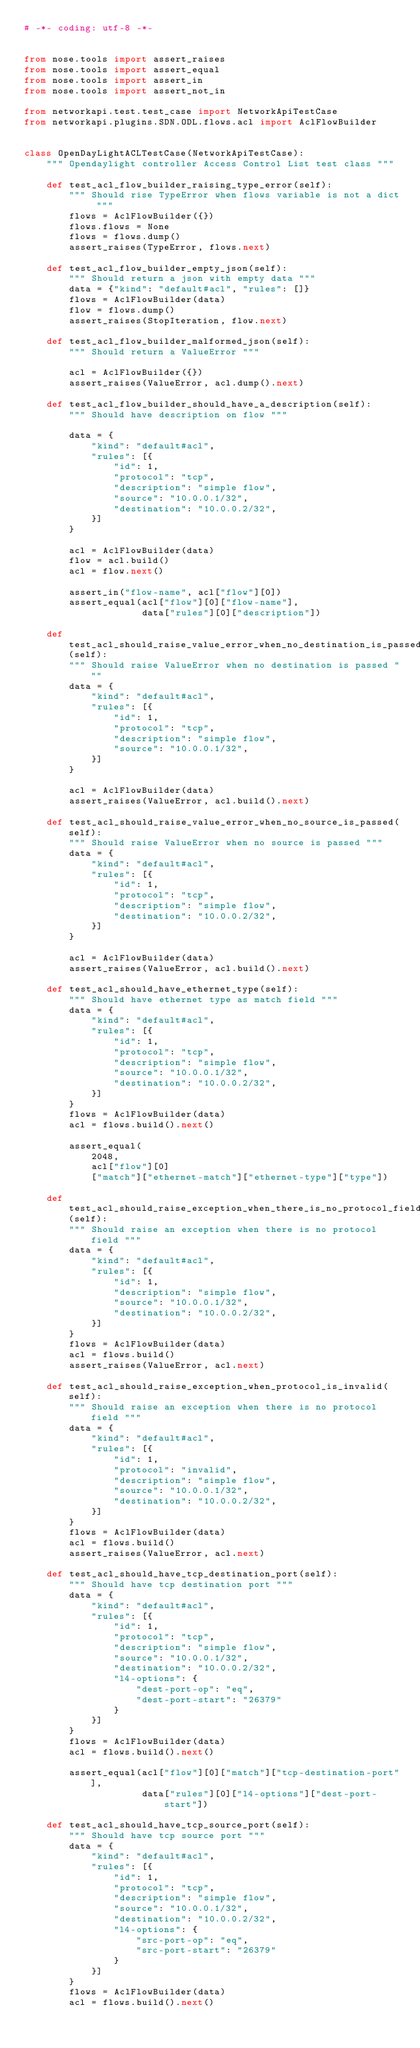<code> <loc_0><loc_0><loc_500><loc_500><_Python_># -*- coding: utf-8 -*-


from nose.tools import assert_raises
from nose.tools import assert_equal
from nose.tools import assert_in
from nose.tools import assert_not_in

from networkapi.test.test_case import NetworkApiTestCase
from networkapi.plugins.SDN.ODL.flows.acl import AclFlowBuilder


class OpenDayLightACLTestCase(NetworkApiTestCase):
    """ Opendaylight controller Access Control List test class """

    def test_acl_flow_builder_raising_type_error(self):
        """ Should rise TypeError when flows variable is not a dict """
        flows = AclFlowBuilder({})
        flows.flows = None
        flows = flows.dump()
        assert_raises(TypeError, flows.next)

    def test_acl_flow_builder_empty_json(self):
        """ Should return a json with empty data """
        data = {"kind": "default#acl", "rules": []}
        flows = AclFlowBuilder(data)
        flow = flows.dump()
        assert_raises(StopIteration, flow.next)

    def test_acl_flow_builder_malformed_json(self):
        """ Should return a ValueError """

        acl = AclFlowBuilder({})
        assert_raises(ValueError, acl.dump().next)

    def test_acl_flow_builder_should_have_a_description(self):
        """ Should have description on flow """

        data = {
            "kind": "default#acl",
            "rules": [{
                "id": 1,
                "protocol": "tcp",
                "description": "simple flow",
                "source": "10.0.0.1/32",
                "destination": "10.0.0.2/32",
            }]
        }

        acl = AclFlowBuilder(data)
        flow = acl.build()
        acl = flow.next()

        assert_in("flow-name", acl["flow"][0])
        assert_equal(acl["flow"][0]["flow-name"],
                     data["rules"][0]["description"])

    def test_acl_should_raise_value_error_when_no_destination_is_passed(self):
        """ Should raise ValueError when no destination is passed """
        data = {
            "kind": "default#acl",
            "rules": [{
                "id": 1,
                "protocol": "tcp",
                "description": "simple flow",
                "source": "10.0.0.1/32",
            }]
        }

        acl = AclFlowBuilder(data)
        assert_raises(ValueError, acl.build().next)

    def test_acl_should_raise_value_error_when_no_source_is_passed(self):
        """ Should raise ValueError when no source is passed """
        data = {
            "kind": "default#acl",
            "rules": [{
                "id": 1,
                "protocol": "tcp",
                "description": "simple flow",
                "destination": "10.0.0.2/32",
            }]
        }

        acl = AclFlowBuilder(data)
        assert_raises(ValueError, acl.build().next)

    def test_acl_should_have_ethernet_type(self):
        """ Should have ethernet type as match field """
        data = {
            "kind": "default#acl",
            "rules": [{
                "id": 1,
                "protocol": "tcp",
                "description": "simple flow",
                "source": "10.0.0.1/32",
                "destination": "10.0.0.2/32",
            }]
        }
        flows = AclFlowBuilder(data)
        acl = flows.build().next()

        assert_equal(
            2048,
            acl["flow"][0]
            ["match"]["ethernet-match"]["ethernet-type"]["type"])

    def test_acl_should_raise_exception_when_there_is_no_protocol_field(self):
        """ Should raise an exception when there is no protocol field """
        data = {
            "kind": "default#acl",
            "rules": [{
                "id": 1,
                "description": "simple flow",
                "source": "10.0.0.1/32",
                "destination": "10.0.0.2/32",
            }]
        }
        flows = AclFlowBuilder(data)
        acl = flows.build()
        assert_raises(ValueError, acl.next)

    def test_acl_should_raise_exception_when_protocol_is_invalid(self):
        """ Should raise an exception when there is no protocol field """
        data = {
            "kind": "default#acl",
            "rules": [{
                "id": 1,
                "protocol": "invalid",
                "description": "simple flow",
                "source": "10.0.0.1/32",
                "destination": "10.0.0.2/32",
            }]
        }
        flows = AclFlowBuilder(data)
        acl = flows.build()
        assert_raises(ValueError, acl.next)

    def test_acl_should_have_tcp_destination_port(self):
        """ Should have tcp destination port """
        data = {
            "kind": "default#acl",
            "rules": [{
                "id": 1,
                "protocol": "tcp",
                "description": "simple flow",
                "source": "10.0.0.1/32",
                "destination": "10.0.0.2/32",
                "l4-options": {
                    "dest-port-op": "eq",
                    "dest-port-start": "26379"
                }
            }]
        }
        flows = AclFlowBuilder(data)
        acl = flows.build().next()

        assert_equal(acl["flow"][0]["match"]["tcp-destination-port"],
                     data["rules"][0]["l4-options"]["dest-port-start"])

    def test_acl_should_have_tcp_source_port(self):
        """ Should have tcp source port """
        data = {
            "kind": "default#acl",
            "rules": [{
                "id": 1,
                "protocol": "tcp",
                "description": "simple flow",
                "source": "10.0.0.1/32",
                "destination": "10.0.0.2/32",
                "l4-options": {
                    "src-port-op": "eq",
                    "src-port-start": "26379"
                }
            }]
        }
        flows = AclFlowBuilder(data)
        acl = flows.build().next()
</code> 